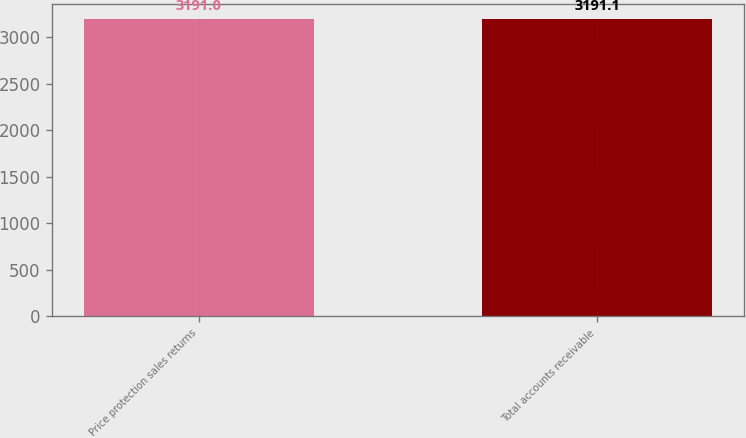<chart> <loc_0><loc_0><loc_500><loc_500><bar_chart><fcel>Price protection sales returns<fcel>Total accounts receivable<nl><fcel>3191<fcel>3191.1<nl></chart> 